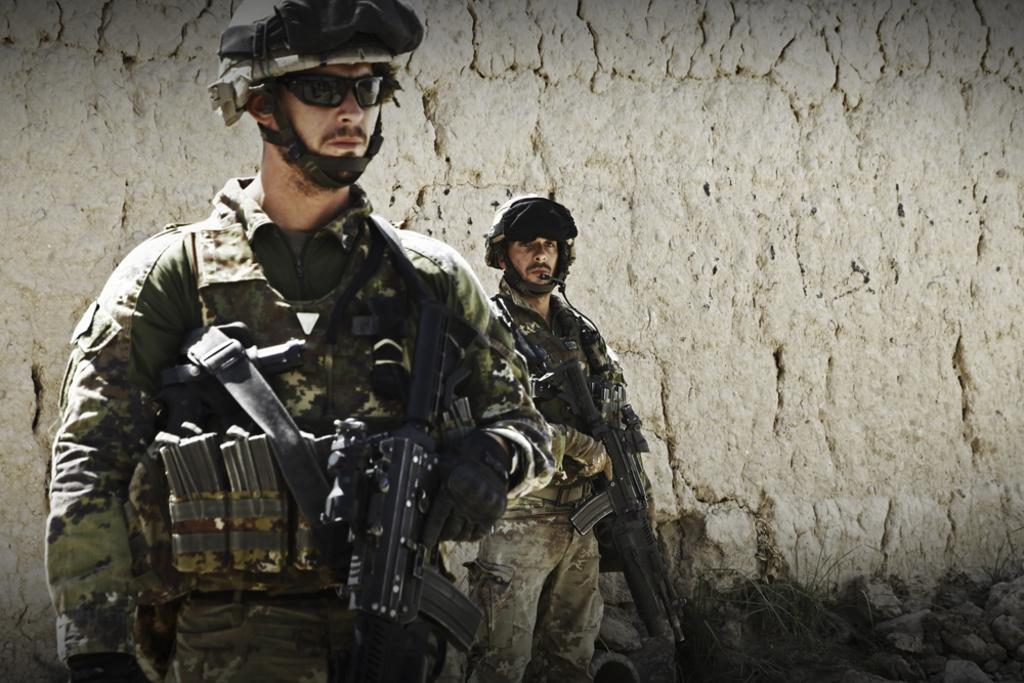In one or two sentences, can you explain what this image depicts? In the image there are two soldiers holding some weapons, they are standing in front of a wall. 